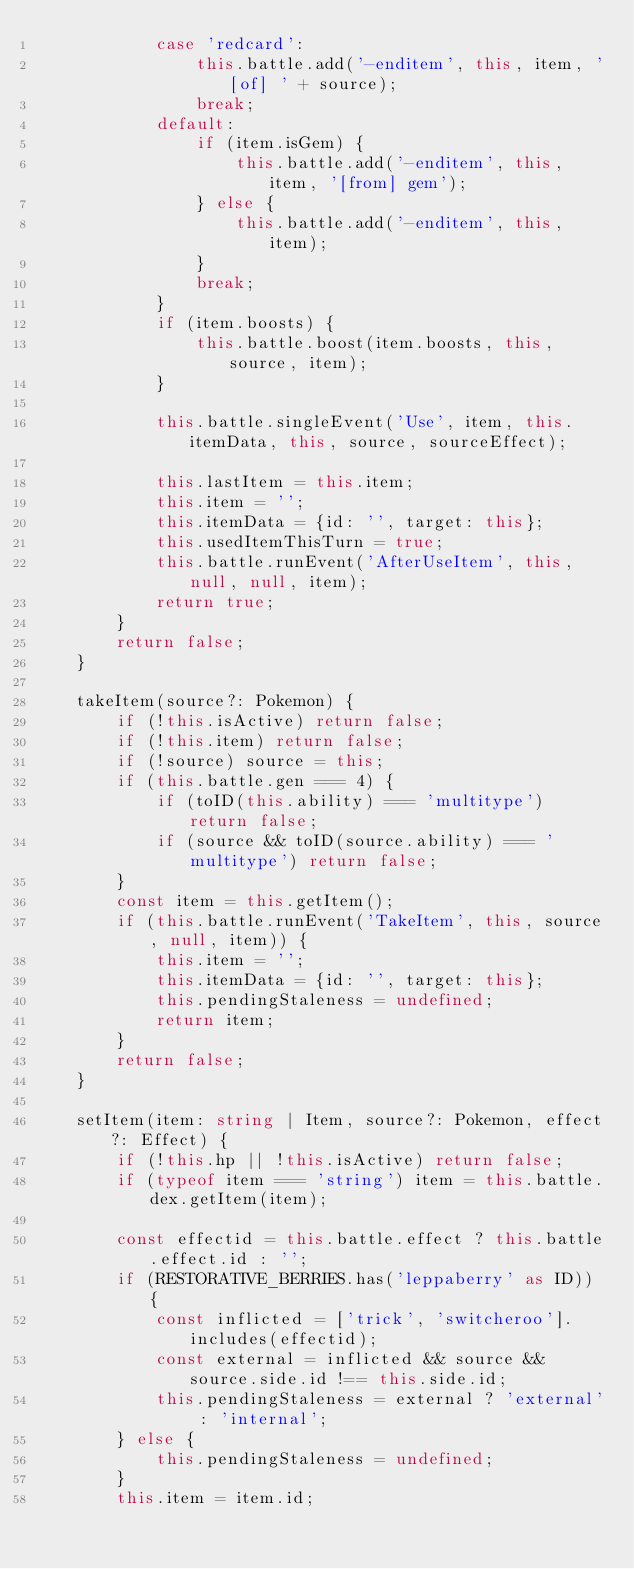<code> <loc_0><loc_0><loc_500><loc_500><_TypeScript_>			case 'redcard':
				this.battle.add('-enditem', this, item, '[of] ' + source);
				break;
			default:
				if (item.isGem) {
					this.battle.add('-enditem', this, item, '[from] gem');
				} else {
					this.battle.add('-enditem', this, item);
				}
				break;
			}
			if (item.boosts) {
				this.battle.boost(item.boosts, this, source, item);
			}

			this.battle.singleEvent('Use', item, this.itemData, this, source, sourceEffect);

			this.lastItem = this.item;
			this.item = '';
			this.itemData = {id: '', target: this};
			this.usedItemThisTurn = true;
			this.battle.runEvent('AfterUseItem', this, null, null, item);
			return true;
		}
		return false;
	}

	takeItem(source?: Pokemon) {
		if (!this.isActive) return false;
		if (!this.item) return false;
		if (!source) source = this;
		if (this.battle.gen === 4) {
			if (toID(this.ability) === 'multitype') return false;
			if (source && toID(source.ability) === 'multitype') return false;
		}
		const item = this.getItem();
		if (this.battle.runEvent('TakeItem', this, source, null, item)) {
			this.item = '';
			this.itemData = {id: '', target: this};
			this.pendingStaleness = undefined;
			return item;
		}
		return false;
	}

	setItem(item: string | Item, source?: Pokemon, effect?: Effect) {
		if (!this.hp || !this.isActive) return false;
		if (typeof item === 'string') item = this.battle.dex.getItem(item);

		const effectid = this.battle.effect ? this.battle.effect.id : '';
		if (RESTORATIVE_BERRIES.has('leppaberry' as ID)) {
			const inflicted = ['trick', 'switcheroo'].includes(effectid);
			const external = inflicted && source && source.side.id !== this.side.id;
			this.pendingStaleness = external ? 'external' : 'internal';
		} else {
			this.pendingStaleness = undefined;
		}
		this.item = item.id;</code> 